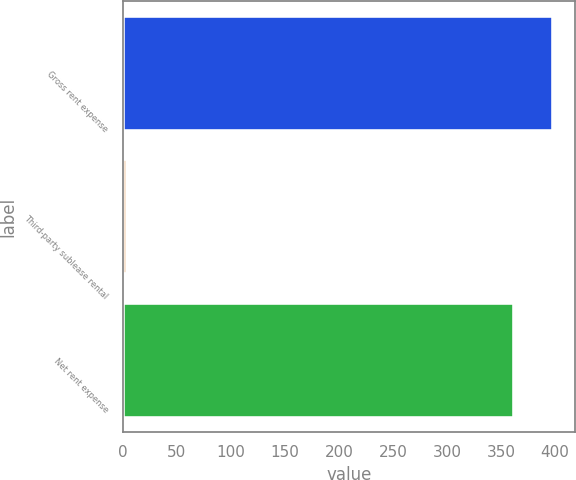Convert chart. <chart><loc_0><loc_0><loc_500><loc_500><bar_chart><fcel>Gross rent expense<fcel>Third-party sublease rental<fcel>Net rent expense<nl><fcel>398.2<fcel>4.1<fcel>362<nl></chart> 